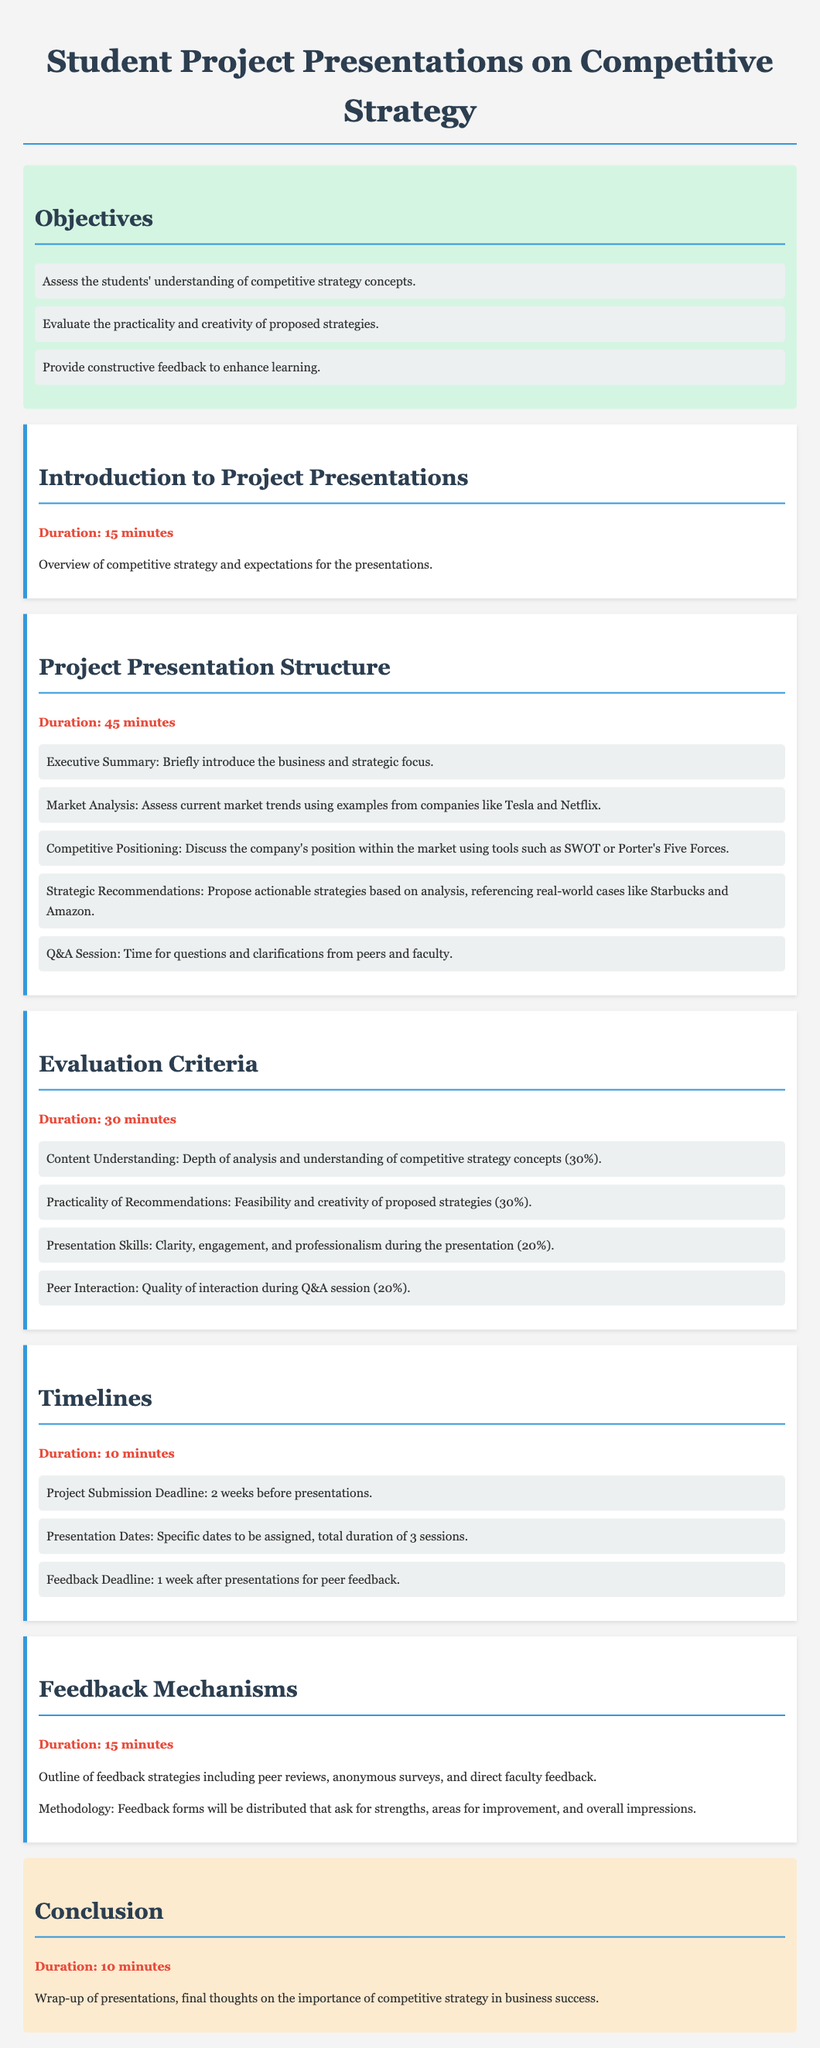what is the duration of the introduction to project presentations? The duration is specified in the document under the introduction section.
Answer: 15 minutes how many criteria are there for evaluation? The document outlines evaluation criteria in a list format, indicating the number of criteria.
Answer: 4 what percentage of the evaluation is based on content understanding? The evaluation criteria section provides the percentage weight for different aspects of the presentations.
Answer: 30% when is the project submission deadline? The timelines section states the project submission deadline in a clear manner.
Answer: 2 weeks before presentations what feedback mechanisms are mentioned in the document? The feedback mechanisms section lists the strategies that will be used for feedback.
Answer: peer reviews, anonymous surveys, direct faculty feedback what is the total duration allocated for the presentation structure? The document specifies the duration allocated for the project presentation structure section.
Answer: 45 minutes what is the feedback deadline? The timelines section specifies when feedback will be due after the presentations.
Answer: 1 week after presentations what is the objective related to providing feedback? The objectives section declares the purpose related to feedback in the context of learning.
Answer: Provide constructive feedback to enhance learning 